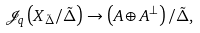Convert formula to latex. <formula><loc_0><loc_0><loc_500><loc_500>\mathcal { J } _ { q } \left ( X _ { \tilde { \Delta } } / \tilde { \Delta } \right ) \rightarrow \left ( A \oplus A ^ { \bot } \right ) / \tilde { \Delta } ,</formula> 